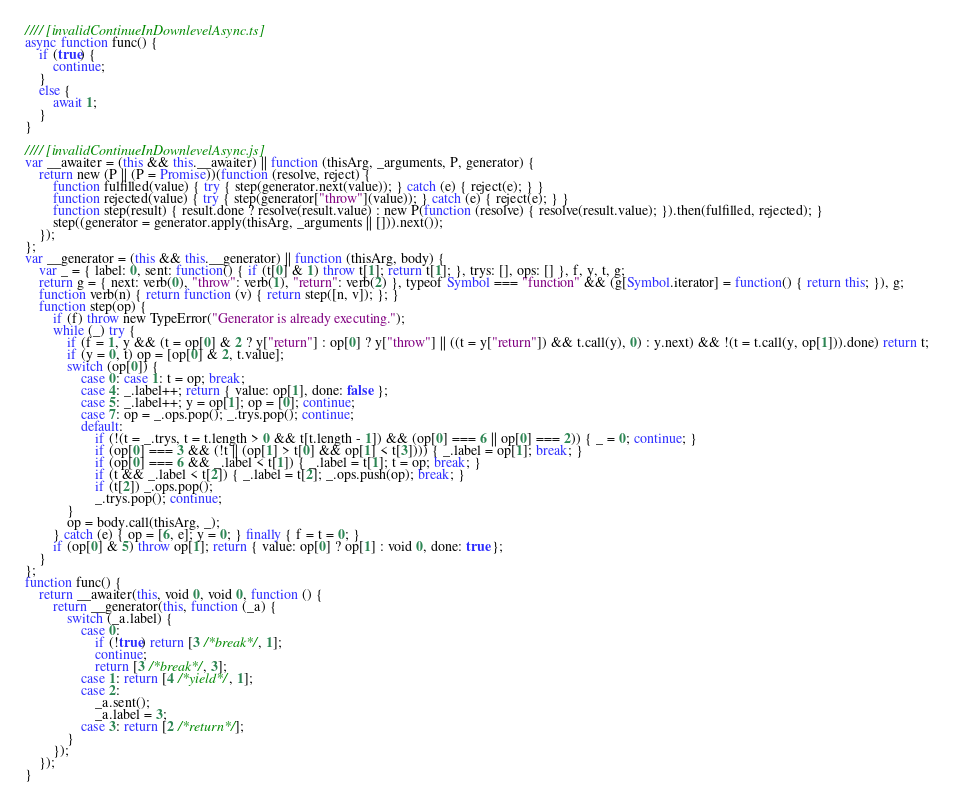Convert code to text. <code><loc_0><loc_0><loc_500><loc_500><_JavaScript_>//// [invalidContinueInDownlevelAsync.ts]
async function func() {
    if (true) {
        continue;
    }
    else {
        await 1;
    }
}

//// [invalidContinueInDownlevelAsync.js]
var __awaiter = (this && this.__awaiter) || function (thisArg, _arguments, P, generator) {
    return new (P || (P = Promise))(function (resolve, reject) {
        function fulfilled(value) { try { step(generator.next(value)); } catch (e) { reject(e); } }
        function rejected(value) { try { step(generator["throw"](value)); } catch (e) { reject(e); } }
        function step(result) { result.done ? resolve(result.value) : new P(function (resolve) { resolve(result.value); }).then(fulfilled, rejected); }
        step((generator = generator.apply(thisArg, _arguments || [])).next());
    });
};
var __generator = (this && this.__generator) || function (thisArg, body) {
    var _ = { label: 0, sent: function() { if (t[0] & 1) throw t[1]; return t[1]; }, trys: [], ops: [] }, f, y, t, g;
    return g = { next: verb(0), "throw": verb(1), "return": verb(2) }, typeof Symbol === "function" && (g[Symbol.iterator] = function() { return this; }), g;
    function verb(n) { return function (v) { return step([n, v]); }; }
    function step(op) {
        if (f) throw new TypeError("Generator is already executing.");
        while (_) try {
            if (f = 1, y && (t = op[0] & 2 ? y["return"] : op[0] ? y["throw"] || ((t = y["return"]) && t.call(y), 0) : y.next) && !(t = t.call(y, op[1])).done) return t;
            if (y = 0, t) op = [op[0] & 2, t.value];
            switch (op[0]) {
                case 0: case 1: t = op; break;
                case 4: _.label++; return { value: op[1], done: false };
                case 5: _.label++; y = op[1]; op = [0]; continue;
                case 7: op = _.ops.pop(); _.trys.pop(); continue;
                default:
                    if (!(t = _.trys, t = t.length > 0 && t[t.length - 1]) && (op[0] === 6 || op[0] === 2)) { _ = 0; continue; }
                    if (op[0] === 3 && (!t || (op[1] > t[0] && op[1] < t[3]))) { _.label = op[1]; break; }
                    if (op[0] === 6 && _.label < t[1]) { _.label = t[1]; t = op; break; }
                    if (t && _.label < t[2]) { _.label = t[2]; _.ops.push(op); break; }
                    if (t[2]) _.ops.pop();
                    _.trys.pop(); continue;
            }
            op = body.call(thisArg, _);
        } catch (e) { op = [6, e]; y = 0; } finally { f = t = 0; }
        if (op[0] & 5) throw op[1]; return { value: op[0] ? op[1] : void 0, done: true };
    }
};
function func() {
    return __awaiter(this, void 0, void 0, function () {
        return __generator(this, function (_a) {
            switch (_a.label) {
                case 0:
                    if (!true) return [3 /*break*/, 1];
                    continue;
                    return [3 /*break*/, 3];
                case 1: return [4 /*yield*/, 1];
                case 2:
                    _a.sent();
                    _a.label = 3;
                case 3: return [2 /*return*/];
            }
        });
    });
}
</code> 